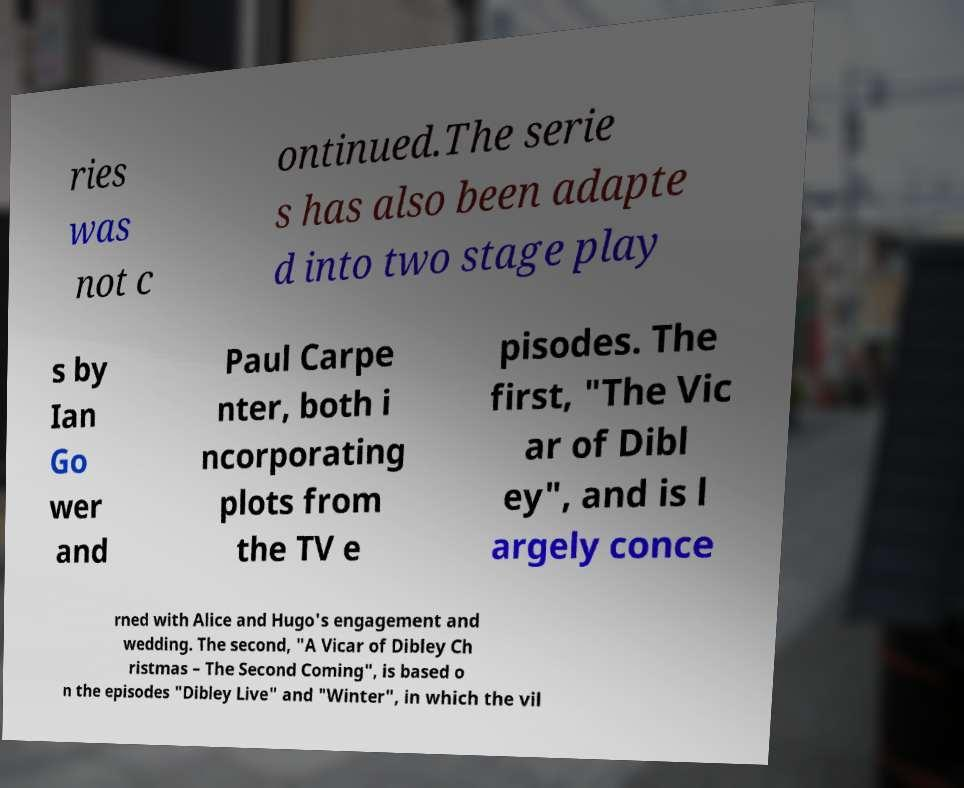What messages or text are displayed in this image? I need them in a readable, typed format. ries was not c ontinued.The serie s has also been adapte d into two stage play s by Ian Go wer and Paul Carpe nter, both i ncorporating plots from the TV e pisodes. The first, "The Vic ar of Dibl ey", and is l argely conce rned with Alice and Hugo's engagement and wedding. The second, "A Vicar of Dibley Ch ristmas – The Second Coming", is based o n the episodes "Dibley Live" and "Winter", in which the vil 